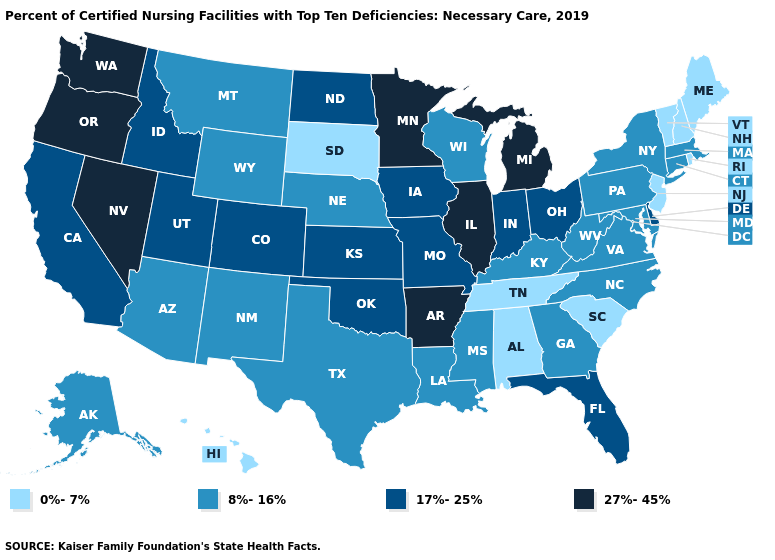What is the value of South Carolina?
Be succinct. 0%-7%. Which states have the lowest value in the West?
Give a very brief answer. Hawaii. What is the highest value in the USA?
Be succinct. 27%-45%. Name the states that have a value in the range 8%-16%?
Be succinct. Alaska, Arizona, Connecticut, Georgia, Kentucky, Louisiana, Maryland, Massachusetts, Mississippi, Montana, Nebraska, New Mexico, New York, North Carolina, Pennsylvania, Texas, Virginia, West Virginia, Wisconsin, Wyoming. What is the highest value in the USA?
Write a very short answer. 27%-45%. What is the lowest value in the MidWest?
Answer briefly. 0%-7%. What is the value of Oregon?
Concise answer only. 27%-45%. What is the value of Massachusetts?
Keep it brief. 8%-16%. Name the states that have a value in the range 27%-45%?
Short answer required. Arkansas, Illinois, Michigan, Minnesota, Nevada, Oregon, Washington. How many symbols are there in the legend?
Be succinct. 4. What is the value of Oregon?
Short answer required. 27%-45%. What is the highest value in states that border Kansas?
Answer briefly. 17%-25%. Among the states that border Georgia , does Florida have the highest value?
Keep it brief. Yes. What is the value of Arizona?
Short answer required. 8%-16%. Which states have the lowest value in the USA?
Give a very brief answer. Alabama, Hawaii, Maine, New Hampshire, New Jersey, Rhode Island, South Carolina, South Dakota, Tennessee, Vermont. 